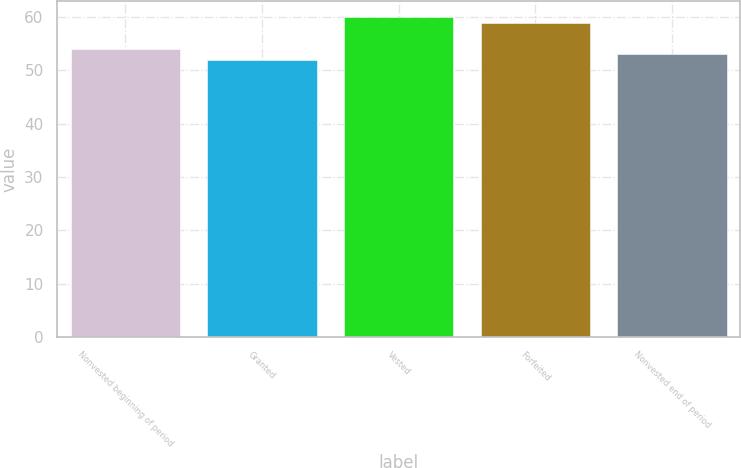Convert chart to OTSL. <chart><loc_0><loc_0><loc_500><loc_500><bar_chart><fcel>Nonvested beginning of period<fcel>Granted<fcel>Vested<fcel>Forfeited<fcel>Nonvested end of period<nl><fcel>54<fcel>52<fcel>60<fcel>59<fcel>53<nl></chart> 